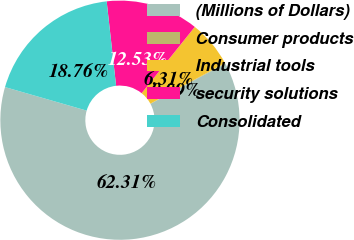Convert chart to OTSL. <chart><loc_0><loc_0><loc_500><loc_500><pie_chart><fcel>(Millions of Dollars)<fcel>Consumer products<fcel>Industrial tools<fcel>security solutions<fcel>Consolidated<nl><fcel>62.3%<fcel>0.09%<fcel>6.31%<fcel>12.53%<fcel>18.76%<nl></chart> 